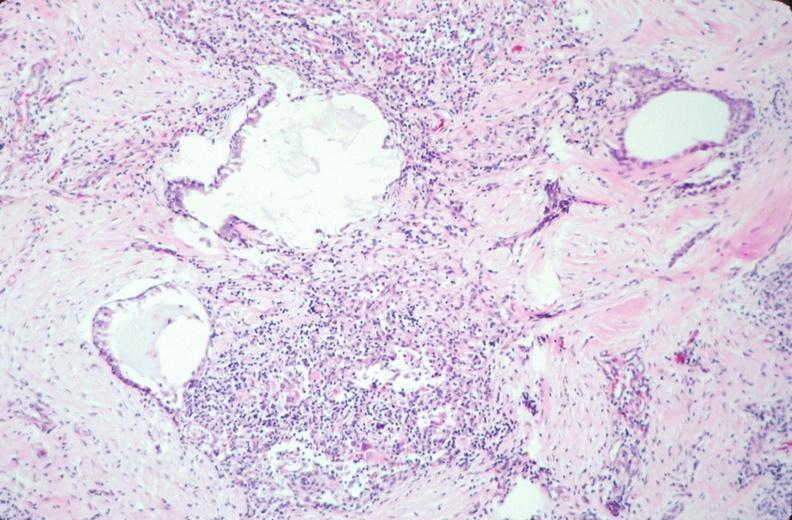s embryo-fetus present?
Answer the question using a single word or phrase. Yes 